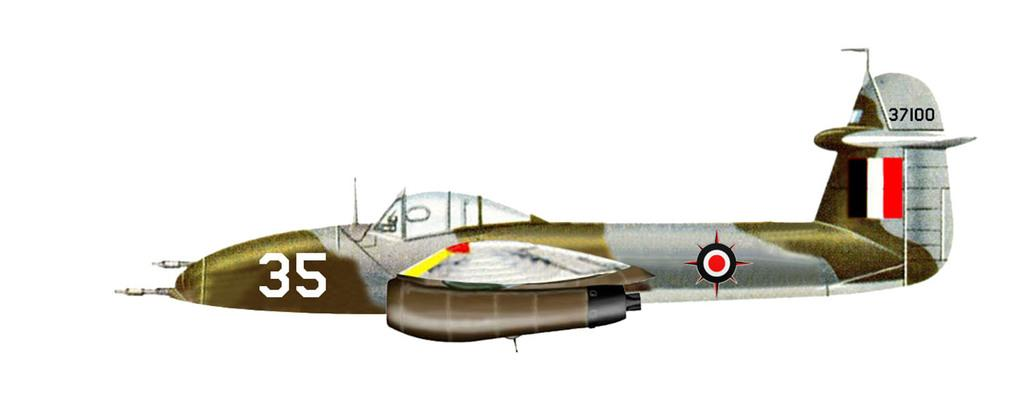What type of vehicle is depicted in the animated image? There is an animated image of a jet plane in the picture. What type of light source is used to illuminate the jet plane in the image? There is no information provided about the light source used in the image, and therefore it cannot be determined from the image. 